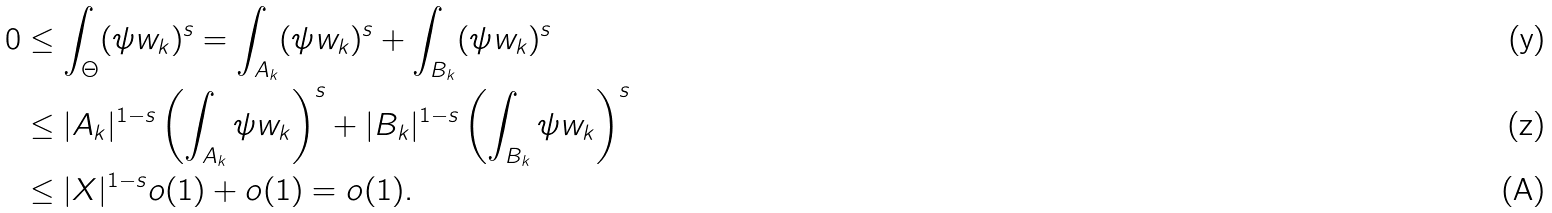<formula> <loc_0><loc_0><loc_500><loc_500>0 & \leq \int _ { \Theta } ( \psi w _ { k } ) ^ { s } = \int _ { A _ { k } } ( \psi w _ { k } ) ^ { s } + \int _ { B _ { k } } ( \psi w _ { k } ) ^ { s } \\ & \leq | A _ { k } | ^ { 1 - s } \left ( \int _ { A _ { k } } \psi w _ { k } \right ) ^ { s } + | B _ { k } | ^ { 1 - s } \left ( \int _ { B _ { k } } \psi w _ { k } \right ) ^ { s } \\ & \leq | X | ^ { 1 - s } o ( 1 ) + o ( 1 ) = o ( 1 ) .</formula> 